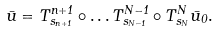Convert formula to latex. <formula><loc_0><loc_0><loc_500><loc_500>\bar { u } = T ^ { n + 1 } _ { s _ { n + 1 } } \circ \dots T ^ { N - 1 } _ { s _ { N - 1 } } \circ T ^ { N } _ { s _ { N } } \bar { u } _ { 0 } .</formula> 